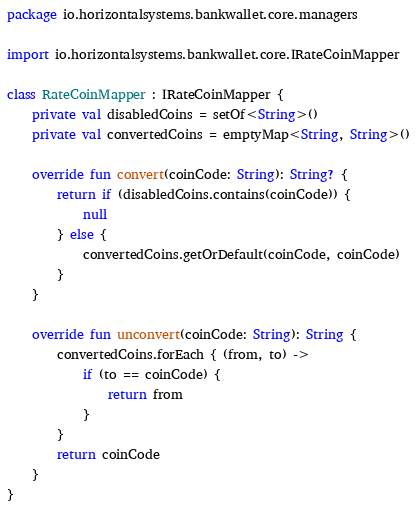<code> <loc_0><loc_0><loc_500><loc_500><_Kotlin_>package io.horizontalsystems.bankwallet.core.managers

import io.horizontalsystems.bankwallet.core.IRateCoinMapper

class RateCoinMapper : IRateCoinMapper {
    private val disabledCoins = setOf<String>()
    private val convertedCoins = emptyMap<String, String>()

    override fun convert(coinCode: String): String? {
        return if (disabledCoins.contains(coinCode)) {
            null
        } else {
            convertedCoins.getOrDefault(coinCode, coinCode)
        }
    }

    override fun unconvert(coinCode: String): String {
        convertedCoins.forEach { (from, to) ->
            if (to == coinCode) {
                return from
            }
        }
        return coinCode
    }
}
</code> 